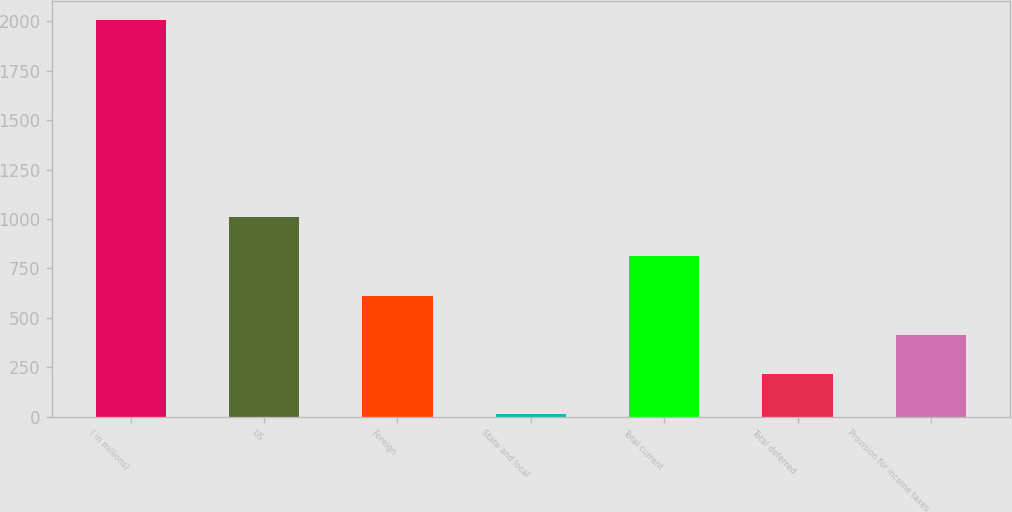Convert chart to OTSL. <chart><loc_0><loc_0><loc_500><loc_500><bar_chart><fcel>( in millions)<fcel>US<fcel>Foreign<fcel>State and local<fcel>Total current<fcel>Total deferred<fcel>Provision for income taxes<nl><fcel>2005<fcel>1010.15<fcel>612.21<fcel>15.3<fcel>811.18<fcel>214.27<fcel>413.24<nl></chart> 